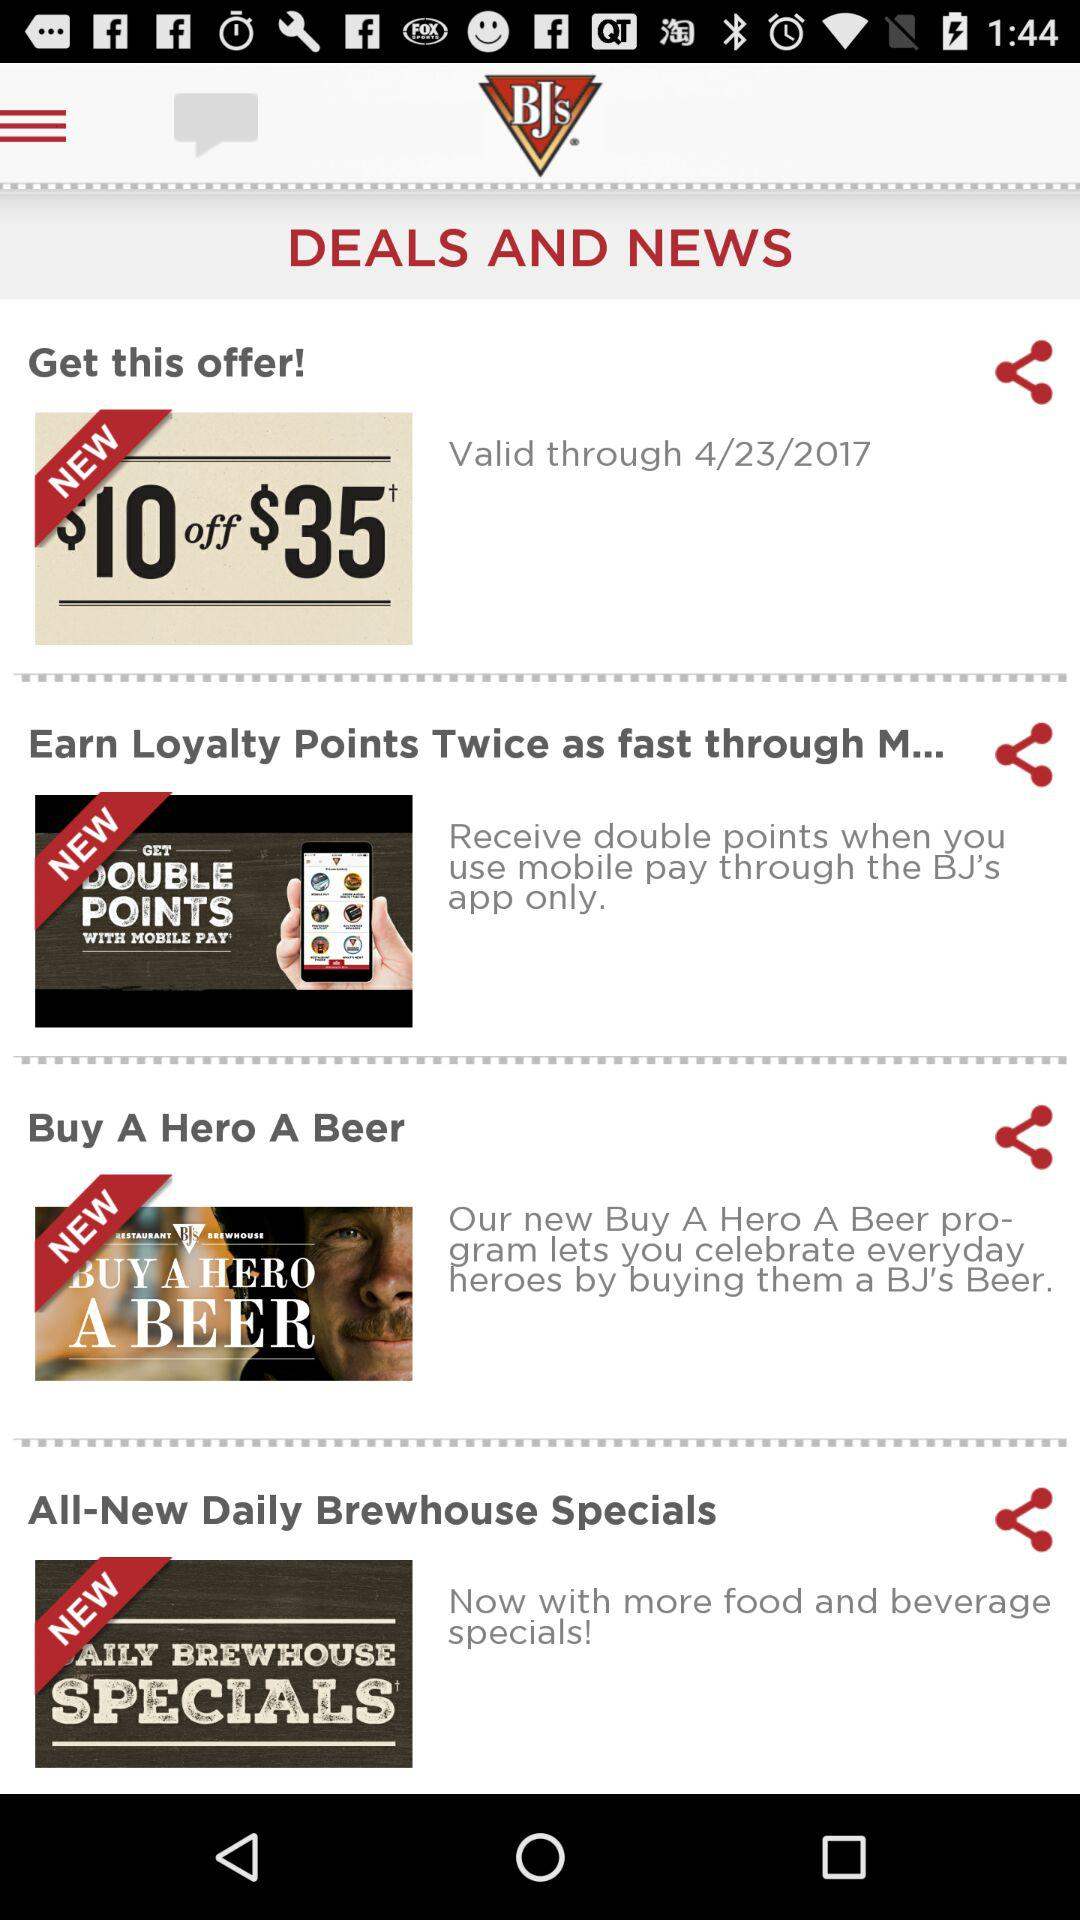What is the offer? The offer is "$10 off $35". 